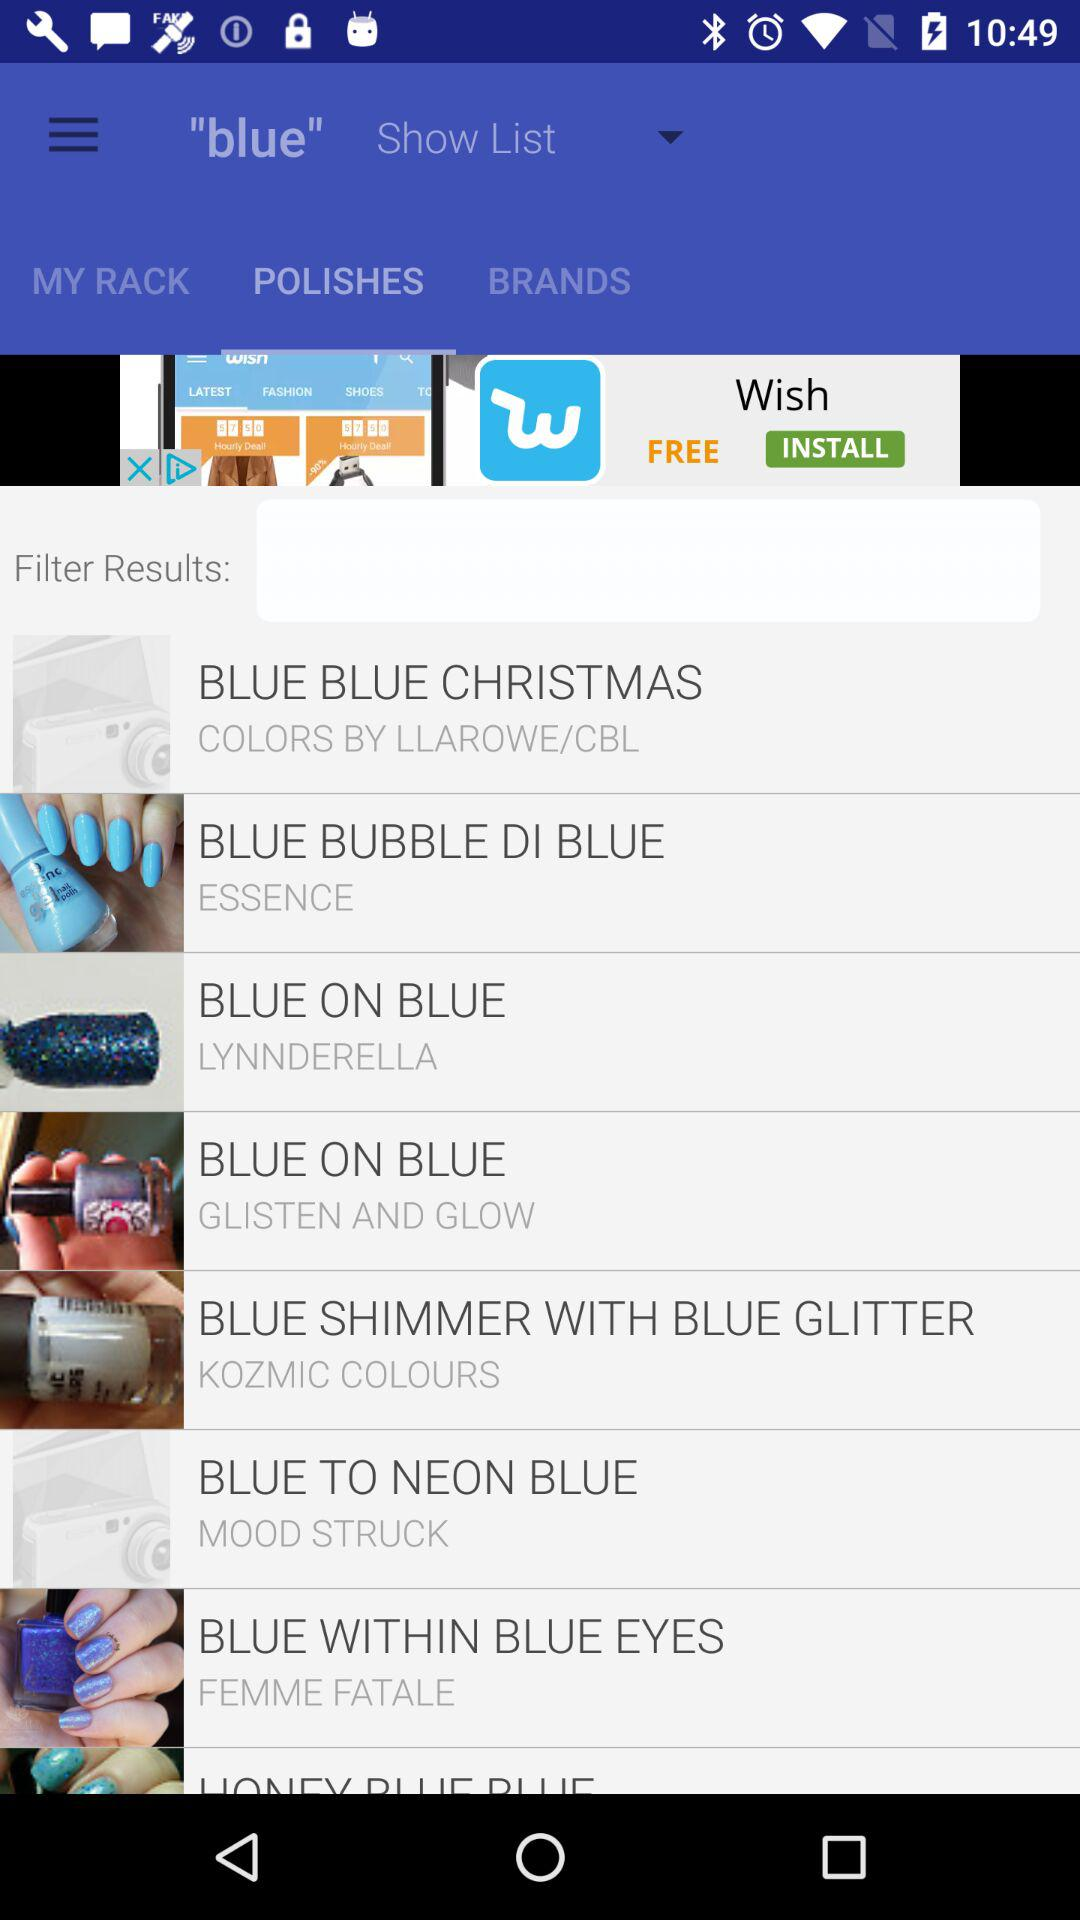What is the application name in the advertisement? The application name in the advertisement is "Wish". 